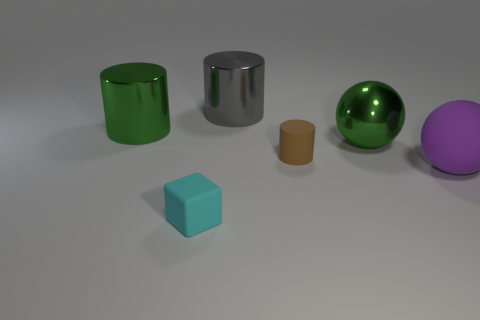Add 2 cyan rubber blocks. How many objects exist? 8 Subtract all spheres. How many objects are left? 4 Add 4 gray cylinders. How many gray cylinders are left? 5 Add 2 metal cylinders. How many metal cylinders exist? 4 Subtract 0 brown spheres. How many objects are left? 6 Subtract all brown cylinders. Subtract all gray cylinders. How many objects are left? 4 